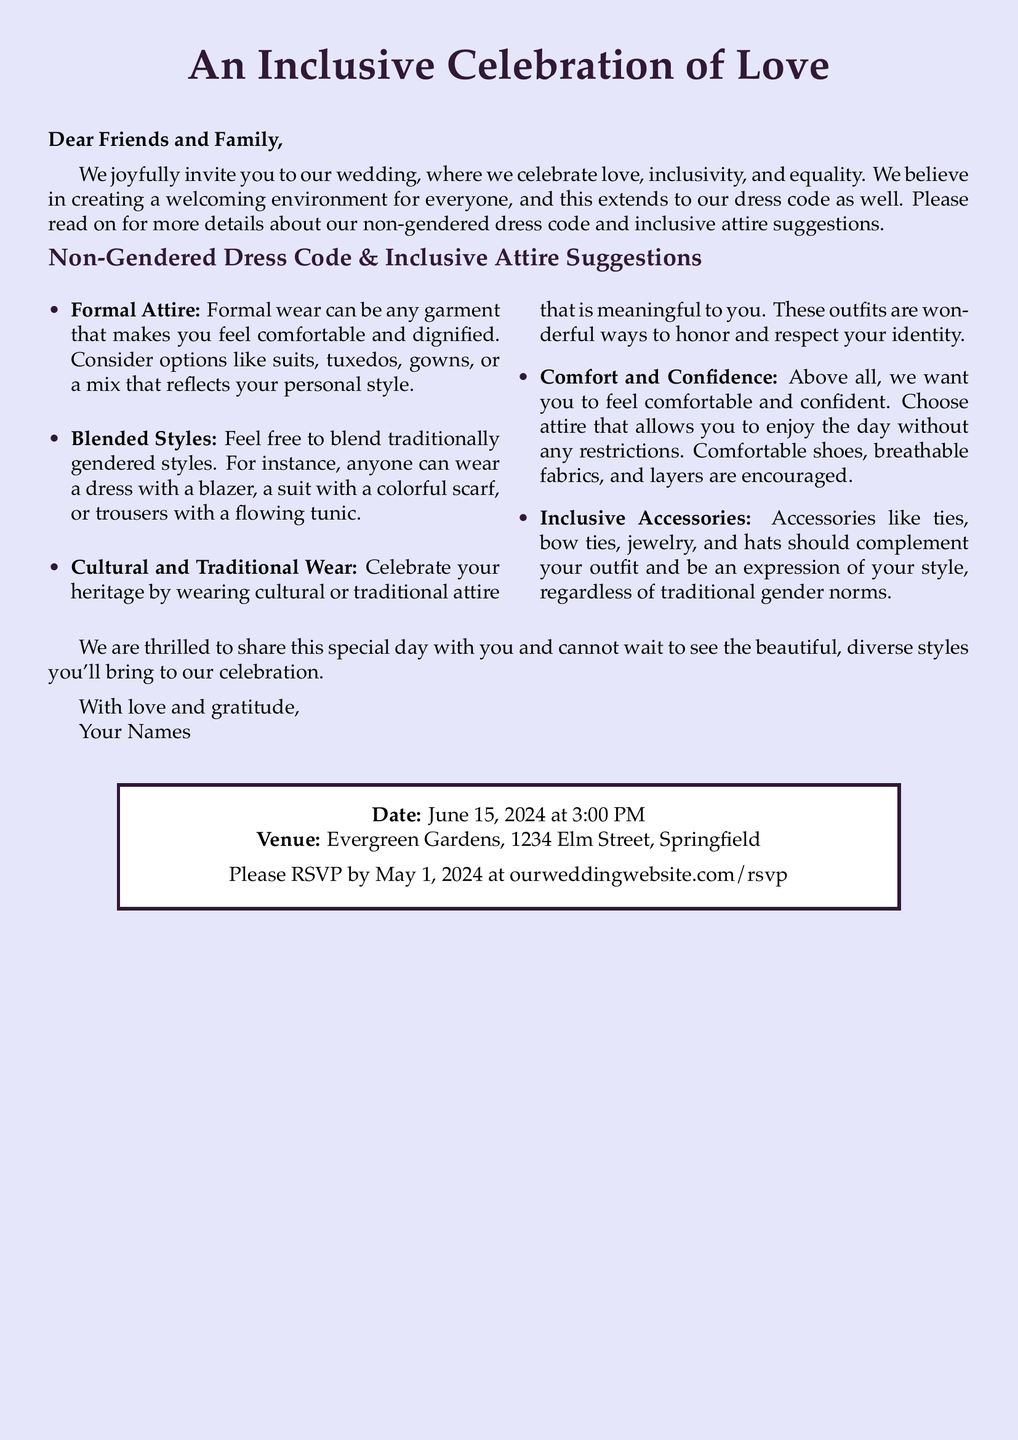what is the date of the wedding? The date of the wedding is explicitly stated in the document, which is June 15, 2024.
Answer: June 15, 2024 what is the location of the wedding? The venue is mentioned in the document, specifically Evergreen Gardens at 1234 Elm Street, Springfield.
Answer: Evergreen Gardens, 1234 Elm Street, Springfield what should guests prioritize in their attire? The document emphasizes that guests should choose attire that allows them to feel comfortable and confident.
Answer: Comfort and confidence what types of attire are suggested in the dress code? The dress code includes formal attire, blended styles, cultural wear, and inclusive accessories, as listed in the document.
Answer: Formal attire, blended styles, cultural wear, inclusive accessories by when should guests RSVP? The RSVP date is indicated in the invitation, which is May 1, 2024.
Answer: May 1, 2024 why is the dress code described as non-gendered? The dress code is non-gendered to create an inclusive environment where everyone can express their personal style without traditional gender norms.
Answer: Inclusivity how does the invitation encourage cultural expression? The document invites guests to wear cultural or traditional attire that reflects their heritage and identity.
Answer: Cultural or traditional attire what color is the background of the invitation? The background color chosen for the document is lavender, as specified in the design choices.
Answer: Lavender 